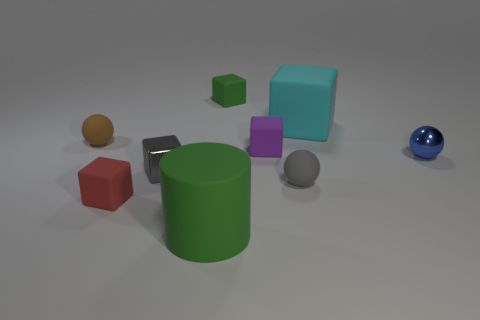What size is the green cylinder?
Provide a short and direct response. Large. What is the tiny gray block made of?
Your answer should be very brief. Metal. Does the matte thing behind the cyan rubber thing have the same size as the large matte cube?
Offer a terse response. No. What number of objects are either gray metallic balls or small rubber objects?
Make the answer very short. 5. What shape is the small rubber thing that is the same color as the small metallic block?
Your answer should be compact. Sphere. There is a matte thing that is behind the tiny purple rubber object and right of the tiny purple rubber thing; how big is it?
Give a very brief answer. Large. What number of small things are there?
Ensure brevity in your answer.  7. How many spheres are either tiny blue objects or brown things?
Offer a terse response. 2. There is a green object in front of the tiny matte thing that is behind the brown matte ball; what number of small metal objects are left of it?
Give a very brief answer. 1. There is a metallic ball that is the same size as the gray rubber object; what is its color?
Give a very brief answer. Blue. 